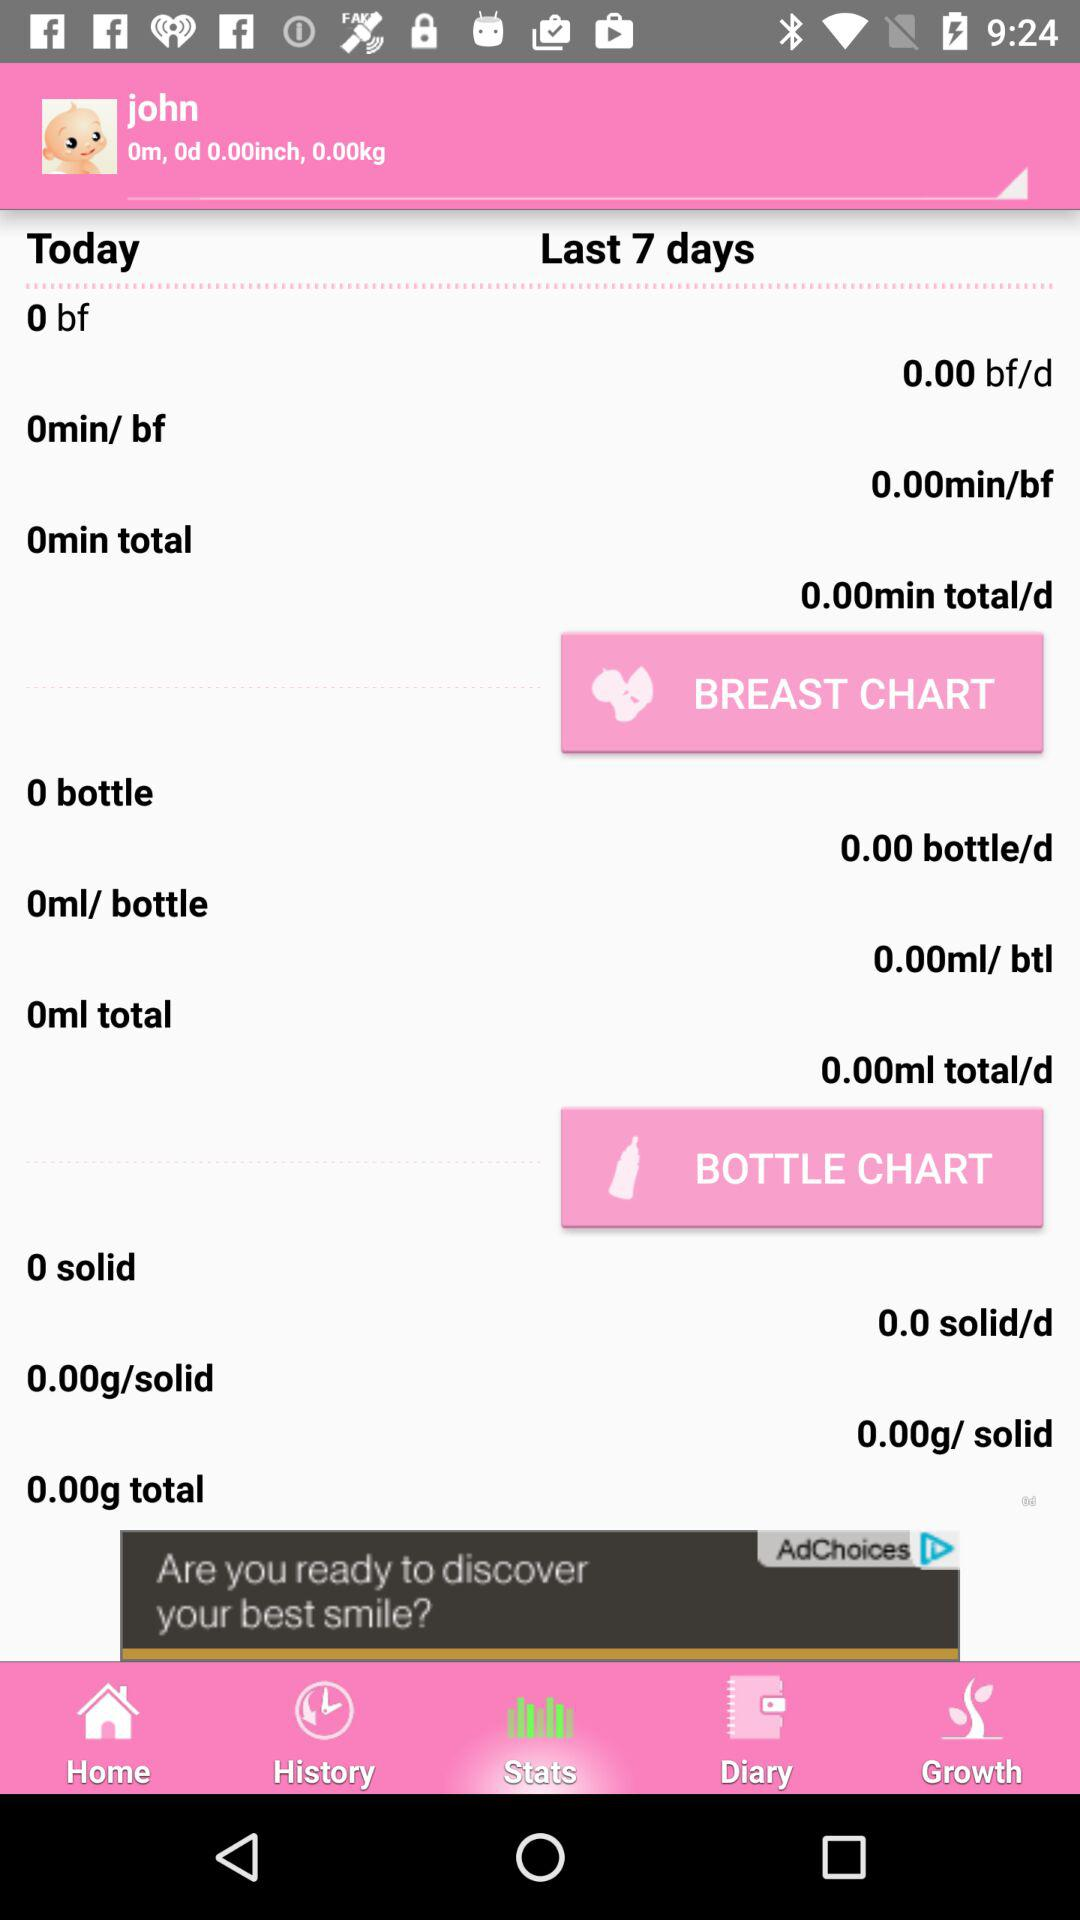What is the baby's name? The baby's name is "john". 